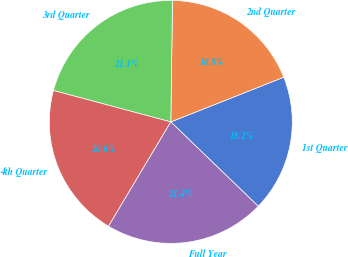Convert chart to OTSL. <chart><loc_0><loc_0><loc_500><loc_500><pie_chart><fcel>1st Quarter<fcel>2nd Quarter<fcel>3rd Quarter<fcel>4th Quarter<fcel>Full Year<nl><fcel>18.21%<fcel>18.78%<fcel>21.06%<fcel>20.6%<fcel>21.35%<nl></chart> 